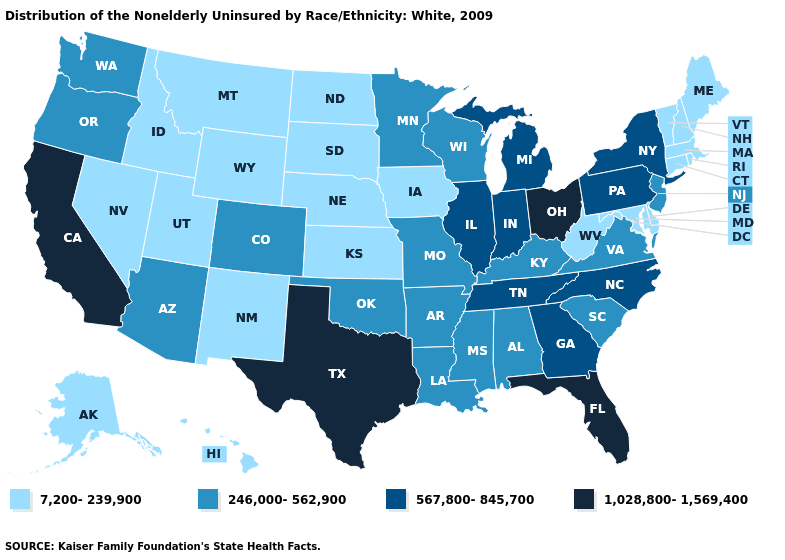Is the legend a continuous bar?
Answer briefly. No. Which states have the lowest value in the USA?
Concise answer only. Alaska, Connecticut, Delaware, Hawaii, Idaho, Iowa, Kansas, Maine, Maryland, Massachusetts, Montana, Nebraska, Nevada, New Hampshire, New Mexico, North Dakota, Rhode Island, South Dakota, Utah, Vermont, West Virginia, Wyoming. Name the states that have a value in the range 1,028,800-1,569,400?
Short answer required. California, Florida, Ohio, Texas. Does Wyoming have a higher value than Alaska?
Be succinct. No. Does the first symbol in the legend represent the smallest category?
Answer briefly. Yes. Name the states that have a value in the range 567,800-845,700?
Be succinct. Georgia, Illinois, Indiana, Michigan, New York, North Carolina, Pennsylvania, Tennessee. Does Nebraska have the lowest value in the USA?
Answer briefly. Yes. What is the highest value in the USA?
Write a very short answer. 1,028,800-1,569,400. Which states have the lowest value in the USA?
Concise answer only. Alaska, Connecticut, Delaware, Hawaii, Idaho, Iowa, Kansas, Maine, Maryland, Massachusetts, Montana, Nebraska, Nevada, New Hampshire, New Mexico, North Dakota, Rhode Island, South Dakota, Utah, Vermont, West Virginia, Wyoming. How many symbols are there in the legend?
Concise answer only. 4. What is the highest value in states that border Indiana?
Quick response, please. 1,028,800-1,569,400. Does Alaska have the lowest value in the USA?
Give a very brief answer. Yes. What is the highest value in the Northeast ?
Be succinct. 567,800-845,700. Name the states that have a value in the range 7,200-239,900?
Concise answer only. Alaska, Connecticut, Delaware, Hawaii, Idaho, Iowa, Kansas, Maine, Maryland, Massachusetts, Montana, Nebraska, Nevada, New Hampshire, New Mexico, North Dakota, Rhode Island, South Dakota, Utah, Vermont, West Virginia, Wyoming. 